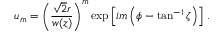Convert formula to latex. <formula><loc_0><loc_0><loc_500><loc_500>u _ { m } = \left ( \frac { \sqrt { 2 } r } { w ( z ) } \right ) ^ { m } \exp \left [ i m \left ( \phi - \tan ^ { - 1 } \zeta \right ) \right ] \, .</formula> 